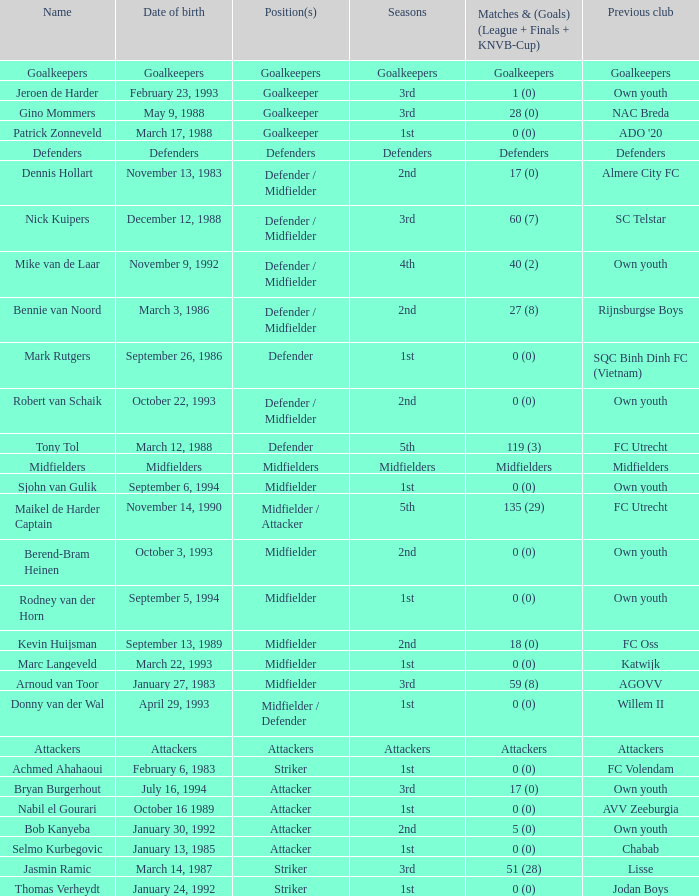What previous club was born on October 22, 1993? Own youth. Help me parse the entirety of this table. {'header': ['Name', 'Date of birth', 'Position(s)', 'Seasons', 'Matches & (Goals) (League + Finals + KNVB-Cup)', 'Previous club'], 'rows': [['Goalkeepers', 'Goalkeepers', 'Goalkeepers', 'Goalkeepers', 'Goalkeepers', 'Goalkeepers'], ['Jeroen de Harder', 'February 23, 1993', 'Goalkeeper', '3rd', '1 (0)', 'Own youth'], ['Gino Mommers', 'May 9, 1988', 'Goalkeeper', '3rd', '28 (0)', 'NAC Breda'], ['Patrick Zonneveld', 'March 17, 1988', 'Goalkeeper', '1st', '0 (0)', "ADO '20"], ['Defenders', 'Defenders', 'Defenders', 'Defenders', 'Defenders', 'Defenders'], ['Dennis Hollart', 'November 13, 1983', 'Defender / Midfielder', '2nd', '17 (0)', 'Almere City FC'], ['Nick Kuipers', 'December 12, 1988', 'Defender / Midfielder', '3rd', '60 (7)', 'SC Telstar'], ['Mike van de Laar', 'November 9, 1992', 'Defender / Midfielder', '4th', '40 (2)', 'Own youth'], ['Bennie van Noord', 'March 3, 1986', 'Defender / Midfielder', '2nd', '27 (8)', 'Rijnsburgse Boys'], ['Mark Rutgers', 'September 26, 1986', 'Defender', '1st', '0 (0)', 'SQC Binh Dinh FC (Vietnam)'], ['Robert van Schaik', 'October 22, 1993', 'Defender / Midfielder', '2nd', '0 (0)', 'Own youth'], ['Tony Tol', 'March 12, 1988', 'Defender', '5th', '119 (3)', 'FC Utrecht'], ['Midfielders', 'Midfielders', 'Midfielders', 'Midfielders', 'Midfielders', 'Midfielders'], ['Sjohn van Gulik', 'September 6, 1994', 'Midfielder', '1st', '0 (0)', 'Own youth'], ['Maikel de Harder Captain', 'November 14, 1990', 'Midfielder / Attacker', '5th', '135 (29)', 'FC Utrecht'], ['Berend-Bram Heinen', 'October 3, 1993', 'Midfielder', '2nd', '0 (0)', 'Own youth'], ['Rodney van der Horn', 'September 5, 1994', 'Midfielder', '1st', '0 (0)', 'Own youth'], ['Kevin Huijsman', 'September 13, 1989', 'Midfielder', '2nd', '18 (0)', 'FC Oss'], ['Marc Langeveld', 'March 22, 1993', 'Midfielder', '1st', '0 (0)', 'Katwijk'], ['Arnoud van Toor', 'January 27, 1983', 'Midfielder', '3rd', '59 (8)', 'AGOVV'], ['Donny van der Wal', 'April 29, 1993', 'Midfielder / Defender', '1st', '0 (0)', 'Willem II'], ['Attackers', 'Attackers', 'Attackers', 'Attackers', 'Attackers', 'Attackers'], ['Achmed Ahahaoui', 'February 6, 1983', 'Striker', '1st', '0 (0)', 'FC Volendam'], ['Bryan Burgerhout', 'July 16, 1994', 'Attacker', '3rd', '17 (0)', 'Own youth'], ['Nabil el Gourari', 'October 16 1989', 'Attacker', '1st', '0 (0)', 'AVV Zeeburgia'], ['Bob Kanyeba', 'January 30, 1992', 'Attacker', '2nd', '5 (0)', 'Own youth'], ['Selmo Kurbegovic', 'January 13, 1985', 'Attacker', '1st', '0 (0)', 'Chabab'], ['Jasmin Ramic', 'March 14, 1987', 'Striker', '3rd', '51 (28)', 'Lisse'], ['Thomas Verheydt', 'January 24, 1992', 'Striker', '1st', '0 (0)', 'Jodan Boys']]} 